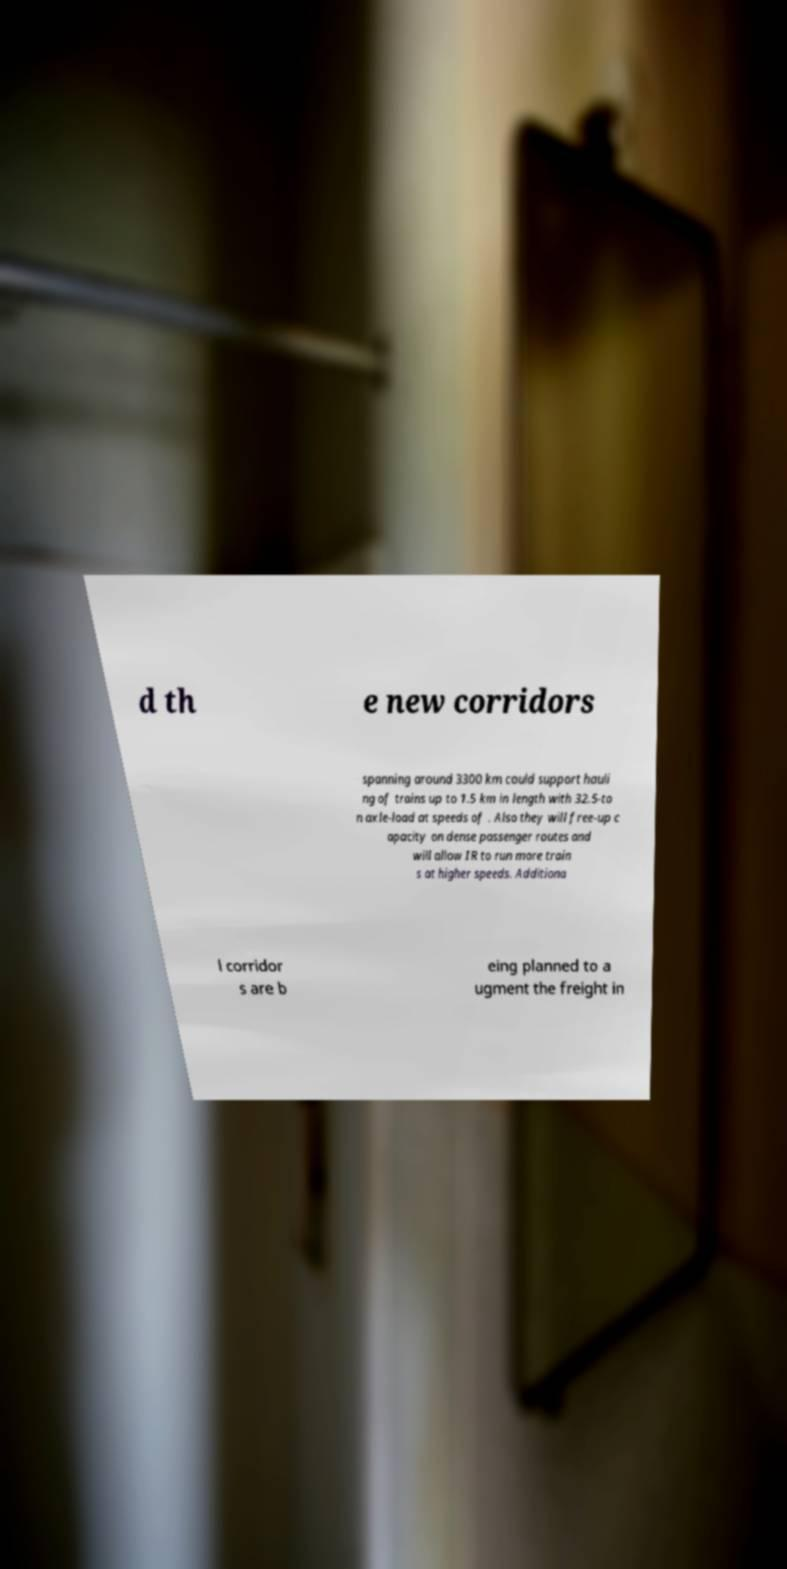Please identify and transcribe the text found in this image. d th e new corridors spanning around 3300 km could support hauli ng of trains up to 1.5 km in length with 32.5-to n axle-load at speeds of . Also they will free-up c apacity on dense passenger routes and will allow IR to run more train s at higher speeds. Additiona l corridor s are b eing planned to a ugment the freight in 